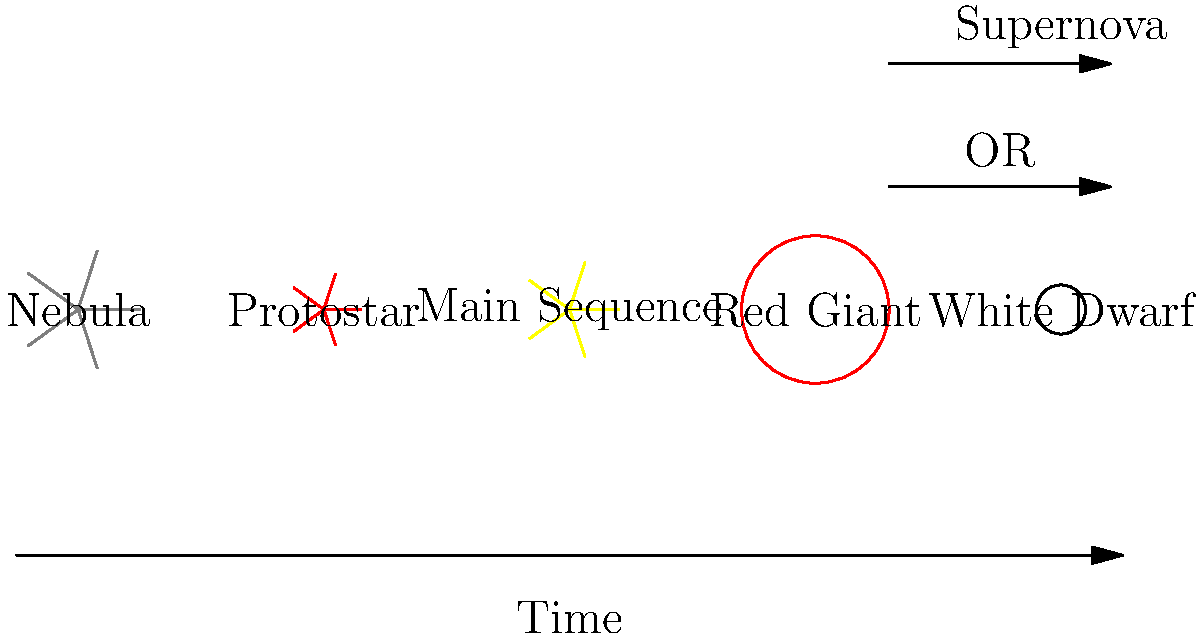As a novel writer exploring the cosmos through your characters' eyes, you're crafting a scene where two lovers discuss the life cycle of stars. Which stage in a star's life comes immediately after the main sequence phase, and what determines whether a star will become a white dwarf or end in a supernova? To answer this question, let's break down the life cycle of stars step by step:

1. Nebula: Stars begin as clouds of gas and dust in space.

2. Protostar: Gravity causes the nebula to collapse, forming a dense, hot core.

3. Main Sequence: The star stabilizes, fusing hydrogen into helium in its core. This is the longest stage of a star's life.

4. Red Giant: After the main sequence, the star expands and cools, becoming a red giant. This is the immediate next stage after the main sequence for all stars.

5. Final Fate: The star's mass determines its ultimate fate:
   a) Low to medium-mass stars (like our Sun):
      - Shed outer layers, forming a planetary nebula
      - Core becomes a white dwarf
   b) High-mass stars:
      - Continue fusing heavier elements
      - Eventually explode as a supernova
      - May leave behind a neutron star or black hole

The key factor determining a star's fate is its initial mass:
- Stars with initial mass < 8 solar masses become white dwarfs
- Stars with initial mass ≥ 8 solar masses end in supernovae

Therefore, the stage immediately after the main sequence is the red giant phase for all stars. The star's initial mass determines whether it will become a white dwarf or end in a supernova.
Answer: Red giant; initial mass (< 8 solar masses: white dwarf, ≥ 8 solar masses: supernova) 